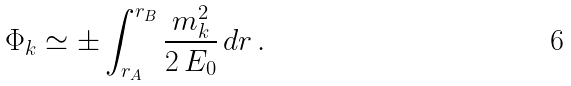Convert formula to latex. <formula><loc_0><loc_0><loc_500><loc_500>\Phi _ { k } \simeq \pm \int _ { r _ { A } } ^ { r _ { B } } \frac { m _ { k } ^ { 2 } } { 2 \, E _ { 0 } } \, d r \, .</formula> 